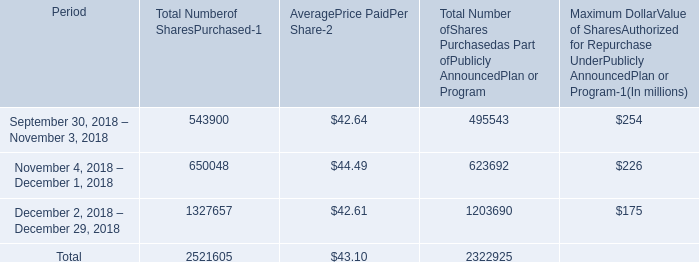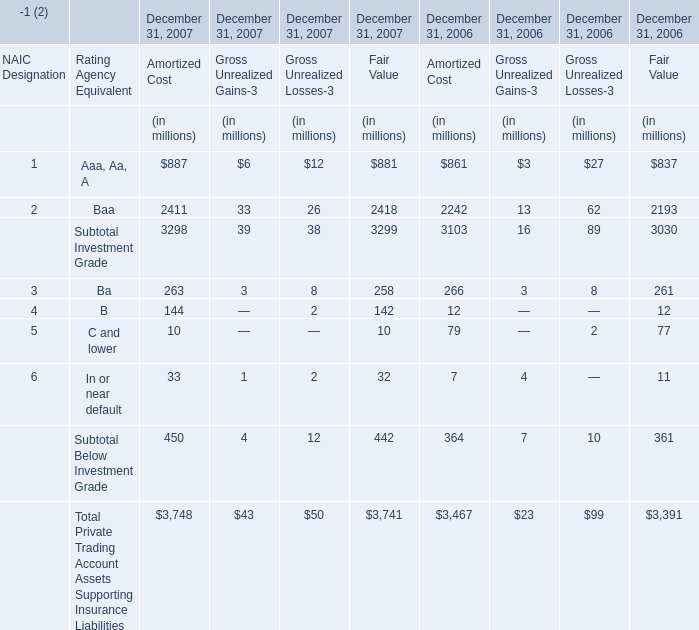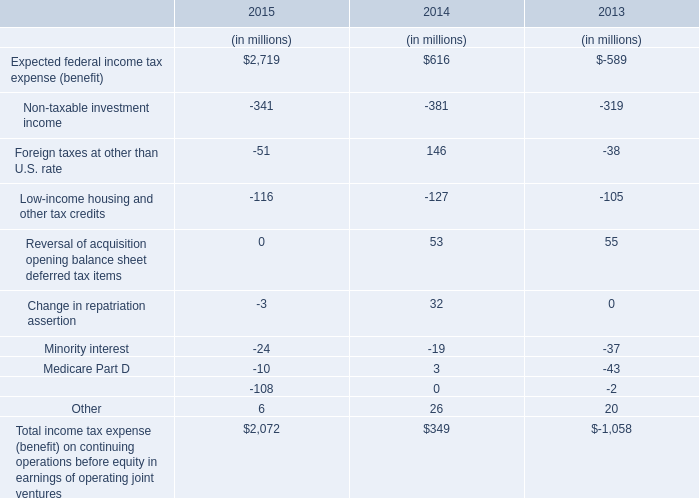Which year is B for Amortized Cost the highest? 
Answer: December 31, 2007. 